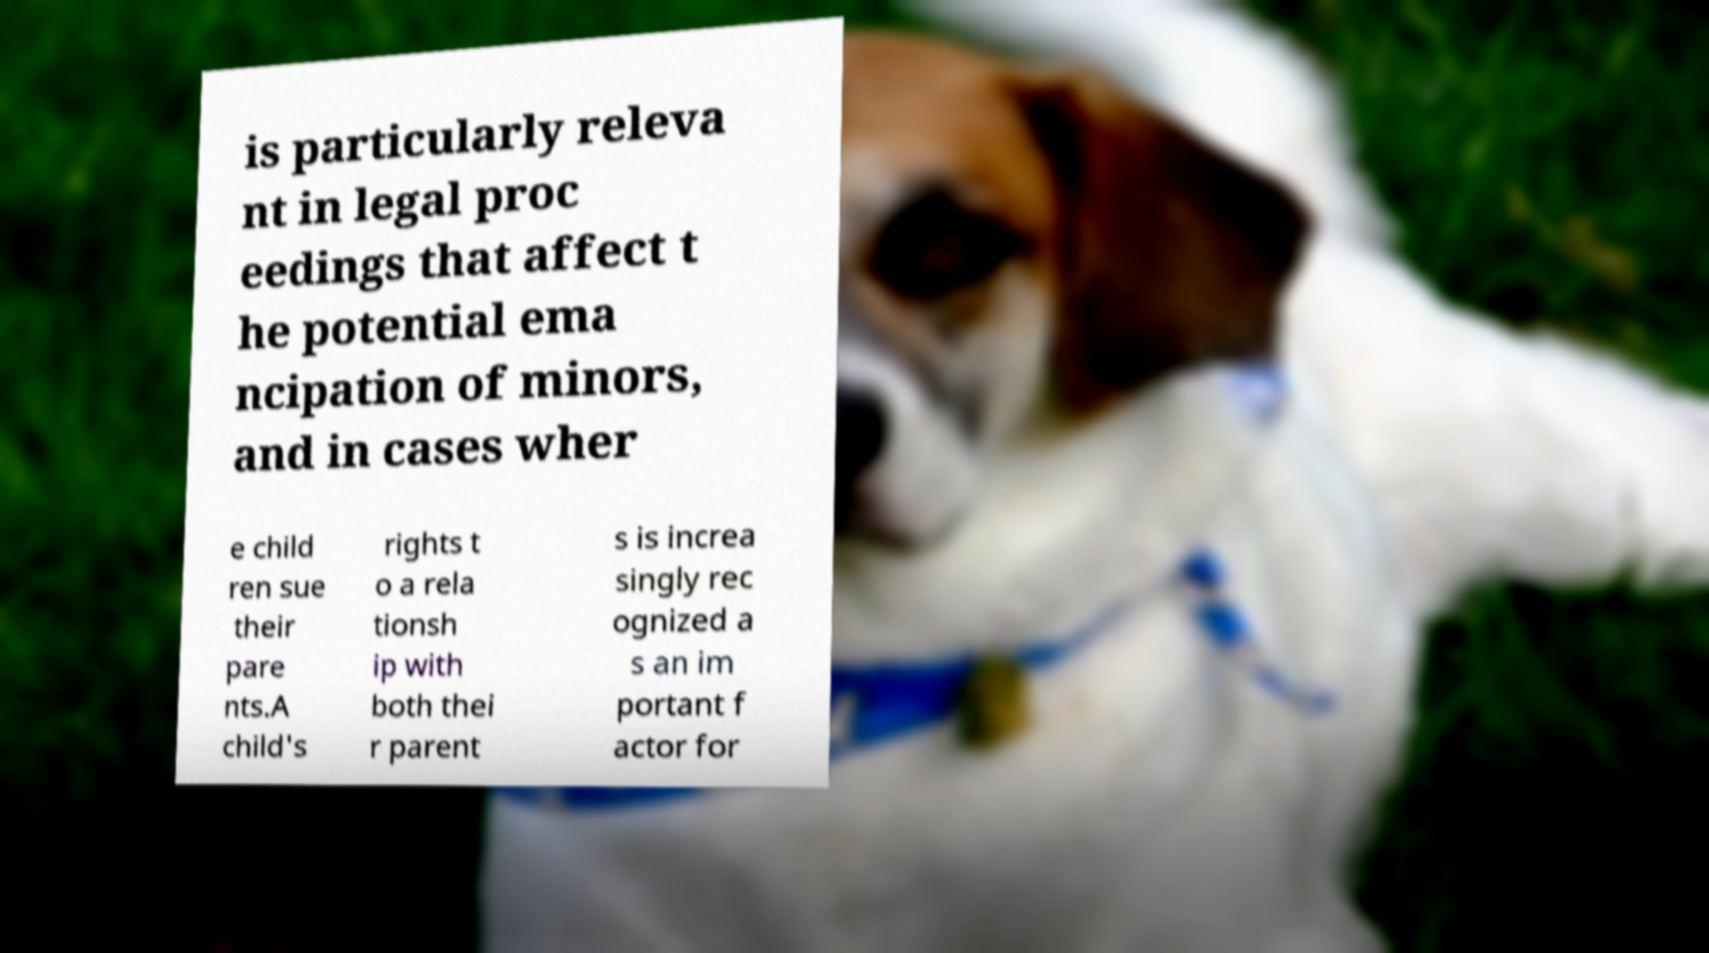Please identify and transcribe the text found in this image. is particularly releva nt in legal proc eedings that affect t he potential ema ncipation of minors, and in cases wher e child ren sue their pare nts.A child's rights t o a rela tionsh ip with both thei r parent s is increa singly rec ognized a s an im portant f actor for 